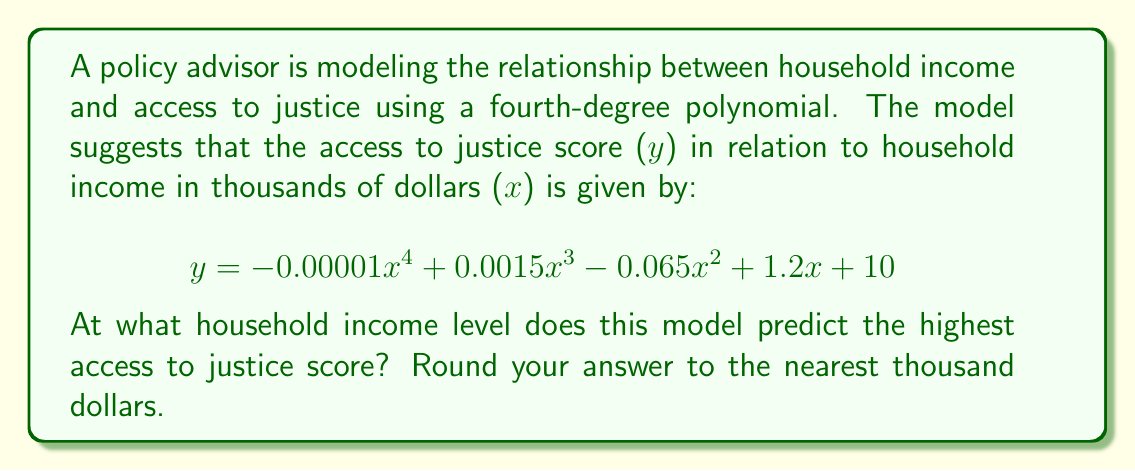Solve this math problem. To find the household income level that predicts the highest access to justice score, we need to find the maximum point of the given polynomial function. This can be done by following these steps:

1) First, we need to find the derivative of the function:
   $$\frac{dy}{dx} = -0.00004x^3 + 0.0045x^2 - 0.13x + 1.2$$

2) To find the maximum point, we set the derivative equal to zero and solve for x:
   $$-0.00004x^3 + 0.0045x^2 - 0.13x + 1.2 = 0$$

3) This is a cubic equation and can be solved using various methods. Using a numerical method or a graphing calculator, we find that this equation has three real roots:
   $x_1 \approx 8.47$, $x_2 \approx 37.41$, and $x_3 \approx 66.62$

4) To determine which of these critical points gives the maximum value, we can either:
   a) Evaluate the original function at each point and compare, or
   b) Use the second derivative test

5) Using method (b), we find the second derivative:
   $$\frac{d^2y}{dx^2} = -0.00012x^2 + 0.009x - 0.13$$

6) Evaluating this at $x = 37.41$ gives a negative value, confirming this is a local maximum.

7) Therefore, the household income level that predicts the highest access to justice score is approximately 37.41 thousand dollars.

8) Rounding to the nearest thousand dollars gives us 37 thousand dollars.
Answer: $37,000 